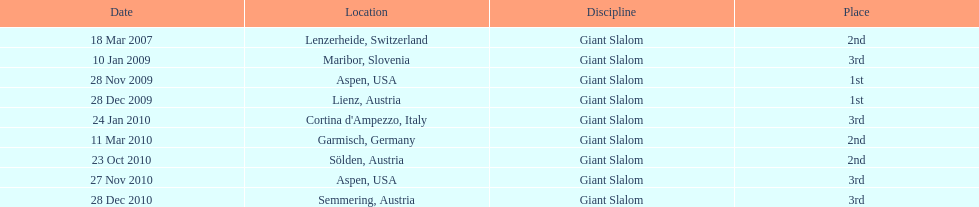In the list provided, what is the sum of her 2nd place finishes? 3. 